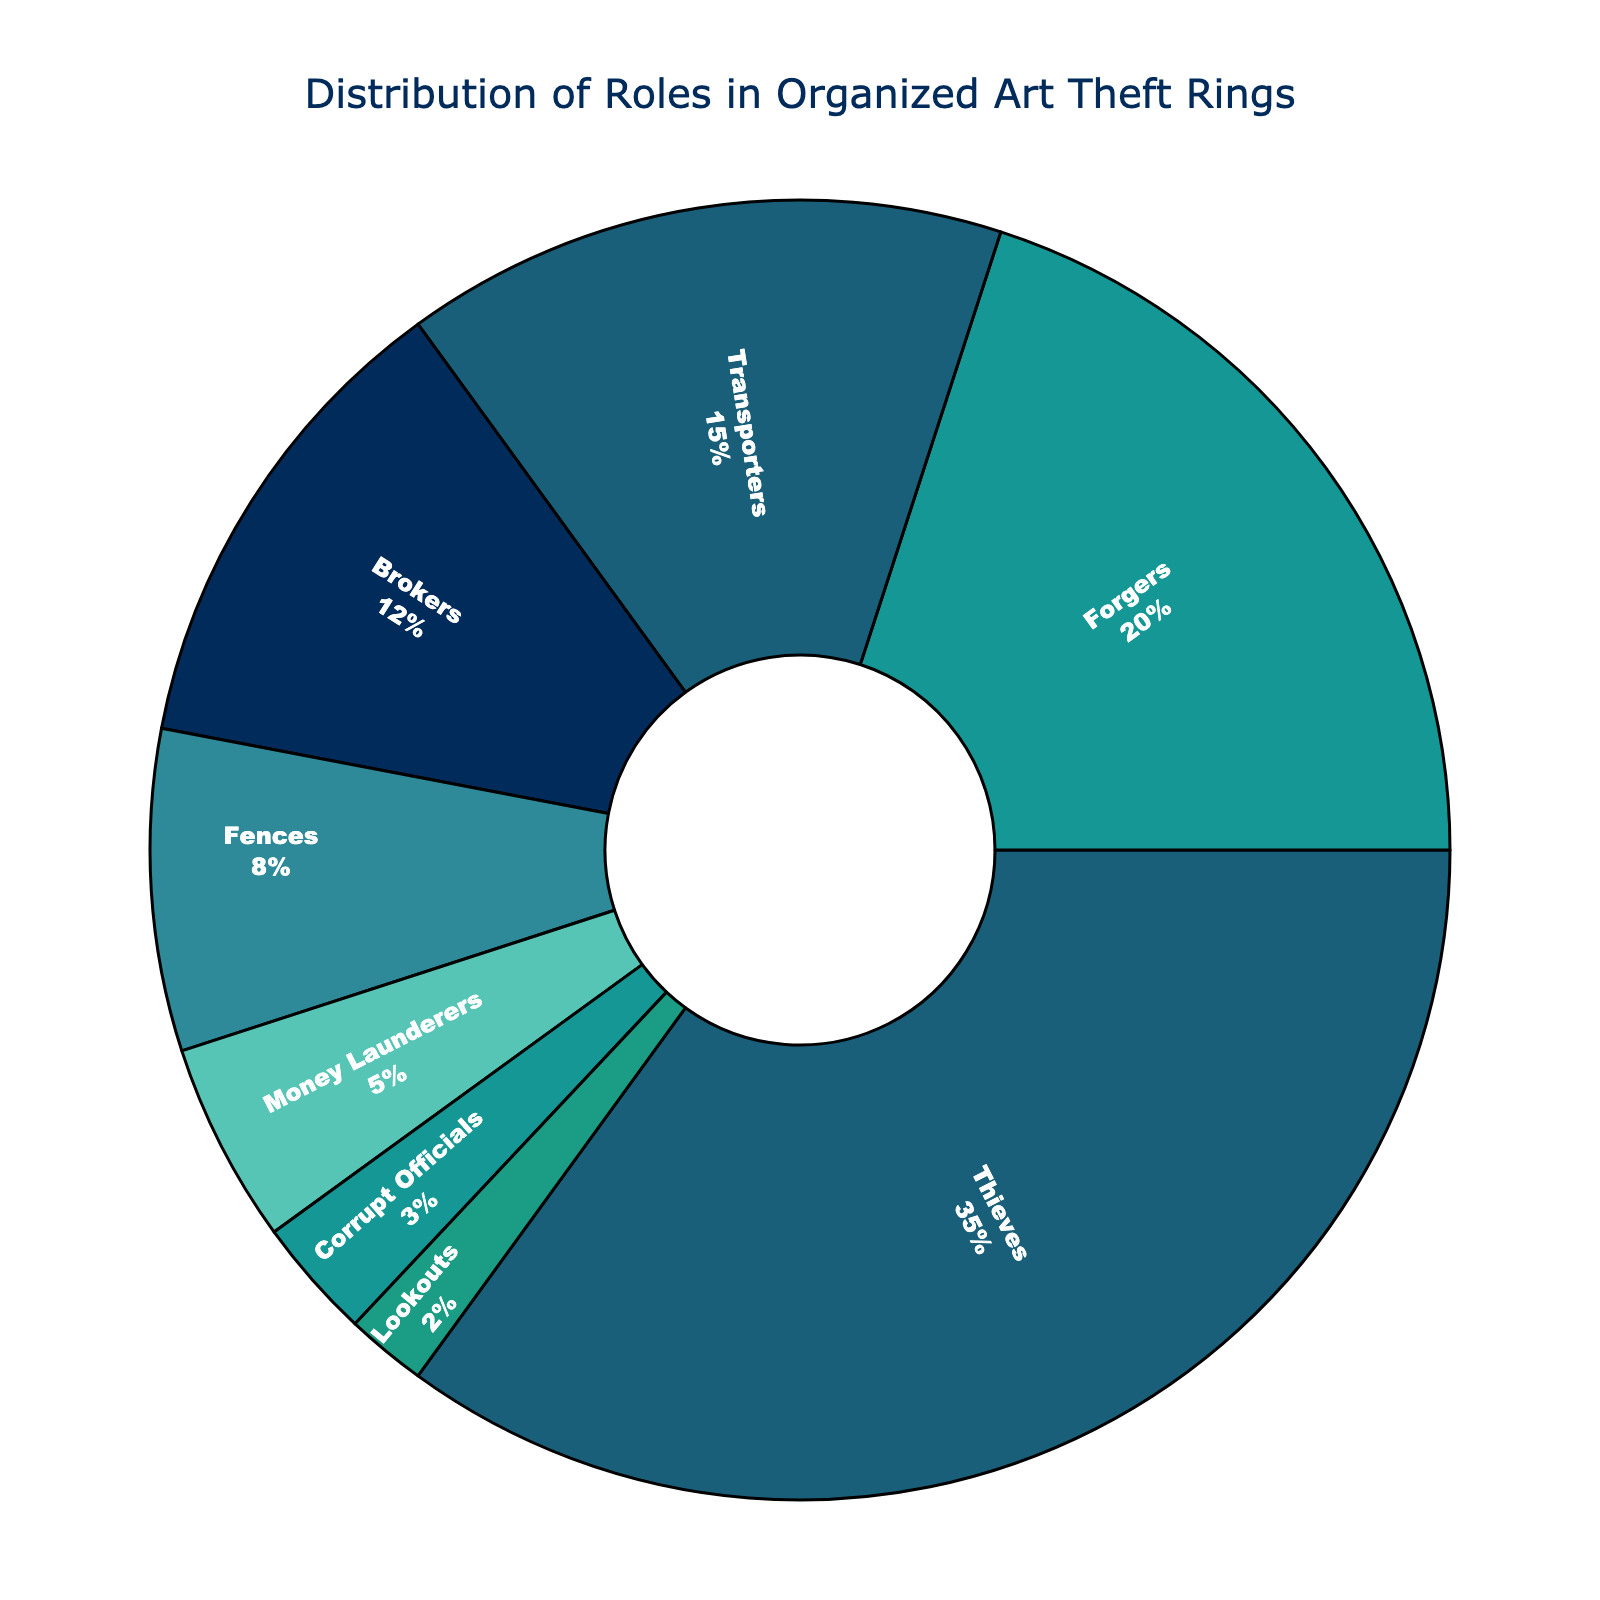What role has the highest percentage in organized art theft rings? Thieves have the highest percentage as indicated in the chart.
Answer: Thieves Which role is more prevalent, Transporters or Brokers? Transporters have a higher percentage (15%) compared to Brokers (12%).
Answer: Transporters What is the combined percentage of Forgers, Fences, and Money Launderers? Adding the percentages: Forgers (20%) + Fences (8%) + Money Launderers (5%) gives the total: 20 + 8 + 5 = 33%
Answer: 33% Are Lookouts more or less prevalent than Corrupt Officials? Lookouts have a lower percentage (2%) compared to Corrupt Officials (3%).
Answer: Less How much more prevalent are Thieves than Money Launderers? Thieves are 35%, and Money Launderers are 5%. The difference is 35 - 5 = 30%.
Answer: 30% Which role has the smallest percentage and what is it? Lookouts have the smallest percentage which is 2%.
Answer: Lookouts What percentage of roles do not directly involve handling stolen art? Adding percentages of non-direct roles: Brokers (12%), Fences (8%), Money Launderers (5%), and Corrupt Officials (3%) gives the total: 12 + 8 + 5 + 3 = 28%.
Answer: 28% If you combine the percentages of Thieves and Forgers, is it more or less than 60%? Thieves are 35% and Forgers are 20%, combined it's 35 + 20 = 55%, which is less than 60%.
Answer: Less How much of the pie chart is occupied by roles related to transporting and handling (Transporters + Brokers + Fences)? Adding the percentages: Transporters (15%) + Brokers (12%) + Fences (8%) gives the total: 15 + 12 + 8 = 35%.
Answer: 35% Which role's segment appears in a blue hue and what is its percentage? Forgers' segment appears in a blue hue and its percentage is 20%.
Answer: Forgers, 20% 